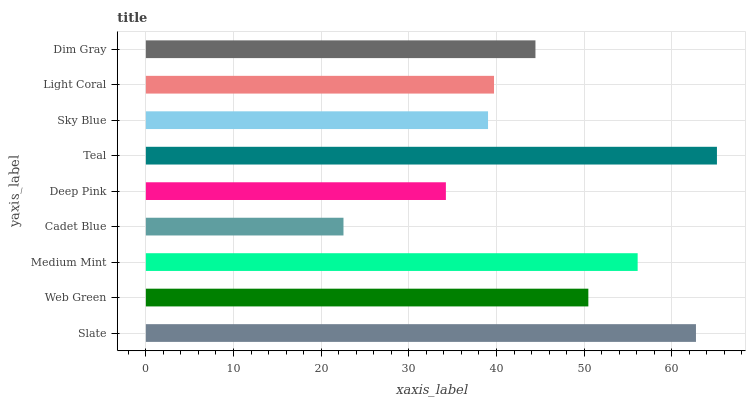Is Cadet Blue the minimum?
Answer yes or no. Yes. Is Teal the maximum?
Answer yes or no. Yes. Is Web Green the minimum?
Answer yes or no. No. Is Web Green the maximum?
Answer yes or no. No. Is Slate greater than Web Green?
Answer yes or no. Yes. Is Web Green less than Slate?
Answer yes or no. Yes. Is Web Green greater than Slate?
Answer yes or no. No. Is Slate less than Web Green?
Answer yes or no. No. Is Dim Gray the high median?
Answer yes or no. Yes. Is Dim Gray the low median?
Answer yes or no. Yes. Is Web Green the high median?
Answer yes or no. No. Is Deep Pink the low median?
Answer yes or no. No. 